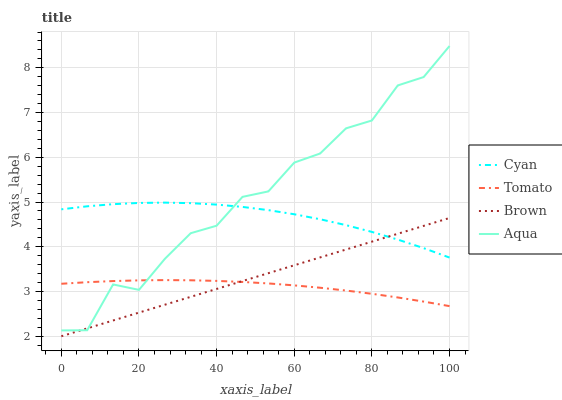Does Tomato have the minimum area under the curve?
Answer yes or no. Yes. Does Aqua have the maximum area under the curve?
Answer yes or no. Yes. Does Cyan have the minimum area under the curve?
Answer yes or no. No. Does Cyan have the maximum area under the curve?
Answer yes or no. No. Is Brown the smoothest?
Answer yes or no. Yes. Is Aqua the roughest?
Answer yes or no. Yes. Is Cyan the smoothest?
Answer yes or no. No. Is Cyan the roughest?
Answer yes or no. No. Does Brown have the lowest value?
Answer yes or no. Yes. Does Aqua have the lowest value?
Answer yes or no. No. Does Aqua have the highest value?
Answer yes or no. Yes. Does Cyan have the highest value?
Answer yes or no. No. Is Tomato less than Cyan?
Answer yes or no. Yes. Is Cyan greater than Tomato?
Answer yes or no. Yes. Does Aqua intersect Brown?
Answer yes or no. Yes. Is Aqua less than Brown?
Answer yes or no. No. Is Aqua greater than Brown?
Answer yes or no. No. Does Tomato intersect Cyan?
Answer yes or no. No. 